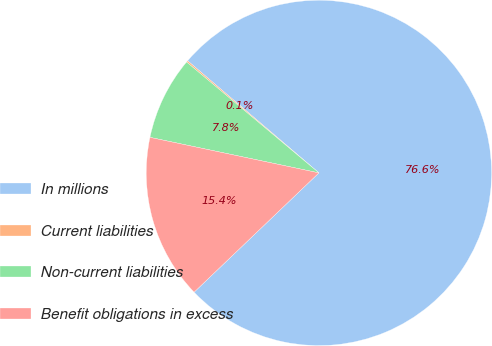<chart> <loc_0><loc_0><loc_500><loc_500><pie_chart><fcel>In millions<fcel>Current liabilities<fcel>Non-current liabilities<fcel>Benefit obligations in excess<nl><fcel>76.61%<fcel>0.15%<fcel>7.8%<fcel>15.44%<nl></chart> 